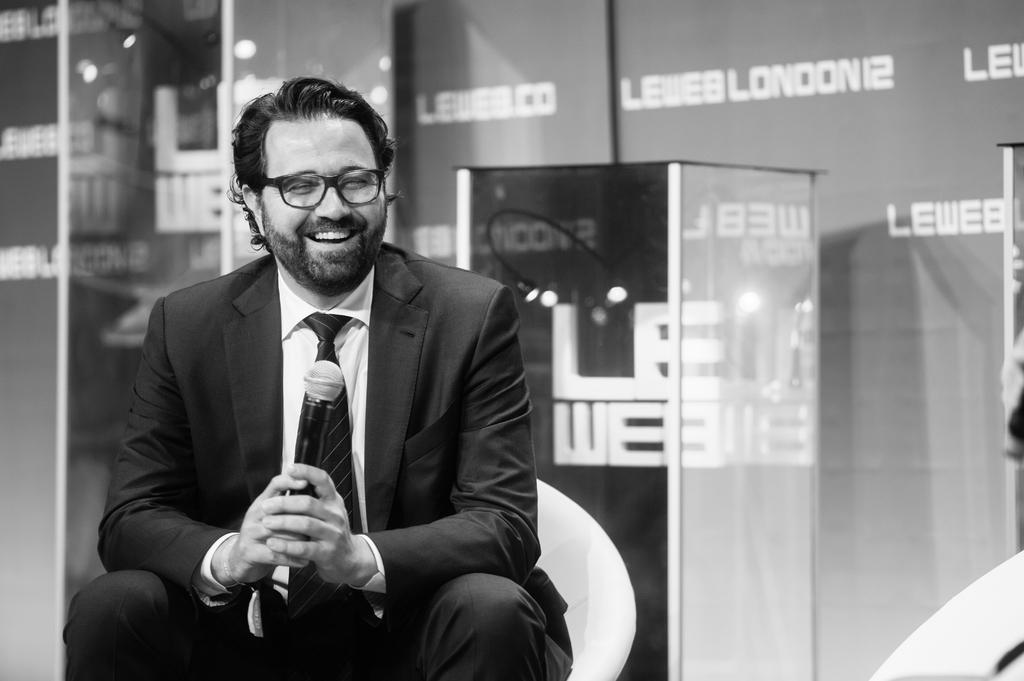What is the main subject in the foreground of the picture? There is a man in the foreground of the picture. What is the man holding in the picture? The man is holding a mic. What is the man's position in the picture? The man is sitting on a chair. What can be seen in the background of the picture? There is a podium and a banner wall in the background of the picture. What type of apple is being used to hammer nails into the lunchroom table in the image? There is no apple or hammer present in the image, nor is there a lunchroom table. 